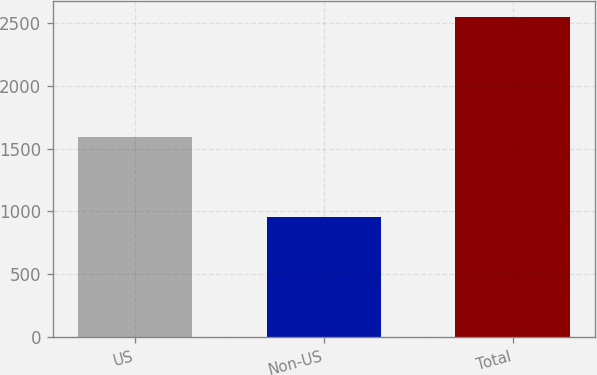<chart> <loc_0><loc_0><loc_500><loc_500><bar_chart><fcel>US<fcel>Non-US<fcel>Total<nl><fcel>1594.5<fcel>954.6<fcel>2549.1<nl></chart> 